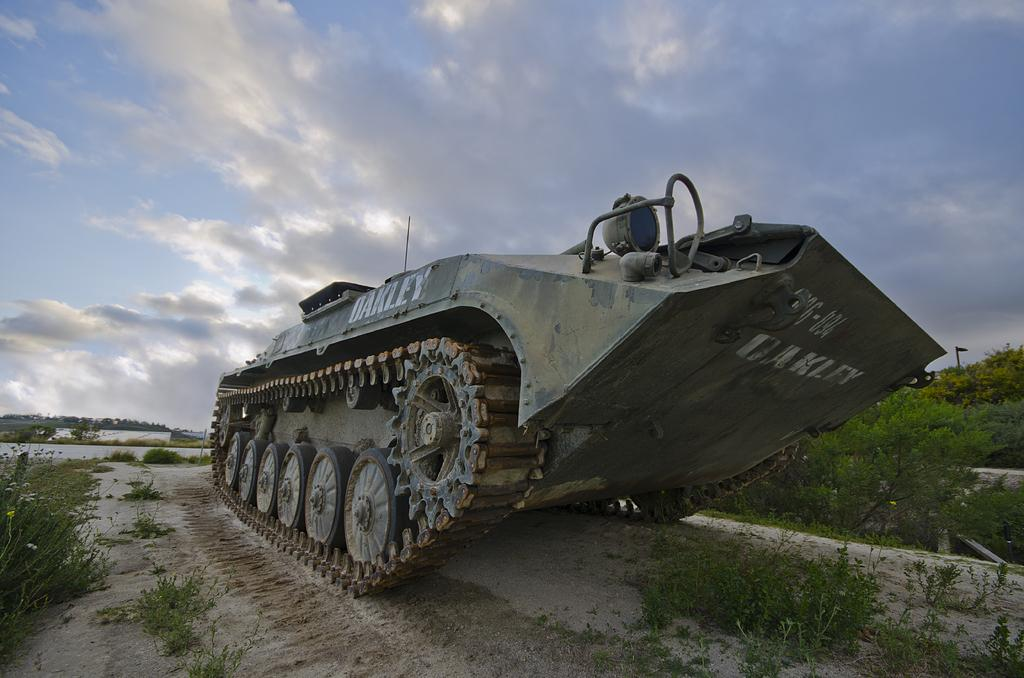Where was the picture taken? The picture was clicked outside. What is the main object in the center of the image? There is a metal tank in the center of the image. What type of vegetation can be seen in the image? There is grass visible in the image, and there are also plants. What can be seen in the background of the image? The sky is visible in the background of the image. What is the weather like in the image? The sky is full of clouds, but there is no mention of rain or sleet, so we cannot determine the weather from the image. What is the distance between the time and the sleet in the image? There is no time or sleet present in the image, so it is not possible to determine a distance between them. 